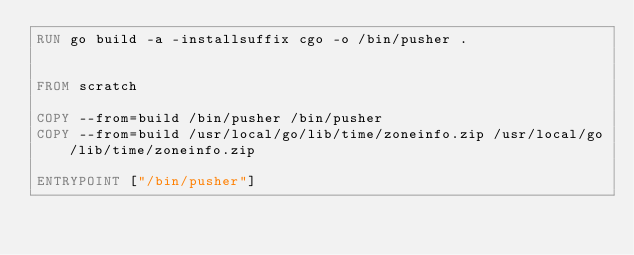<code> <loc_0><loc_0><loc_500><loc_500><_Dockerfile_>RUN go build -a -installsuffix cgo -o /bin/pusher .


FROM scratch

COPY --from=build /bin/pusher /bin/pusher
COPY --from=build /usr/local/go/lib/time/zoneinfo.zip /usr/local/go/lib/time/zoneinfo.zip

ENTRYPOINT ["/bin/pusher"]
</code> 